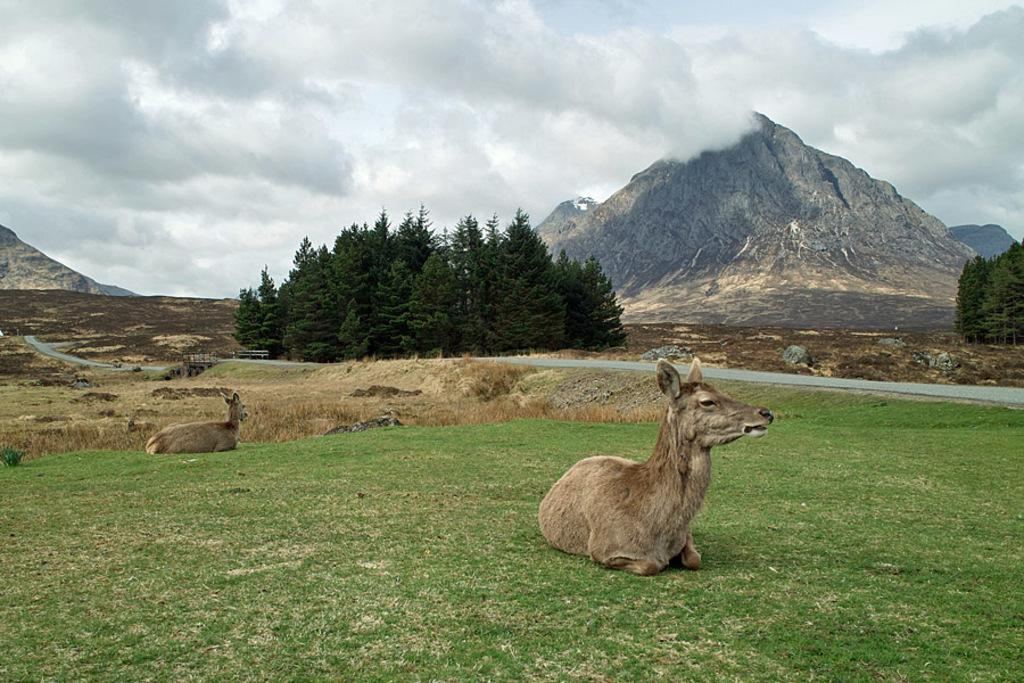What are the two animals in the image doing? The two animals are sitting on the grassland. What can be seen in the image besides the animals? There is a road visible in the image, as well as trees, hills, and the sky in the background. What is the weather like in the image? The sky is visible in the background, and clouds are present, suggesting a partly cloudy day. What does the locket around the neck of the animal say? There is no locket present around the neck of the animals in the image. 